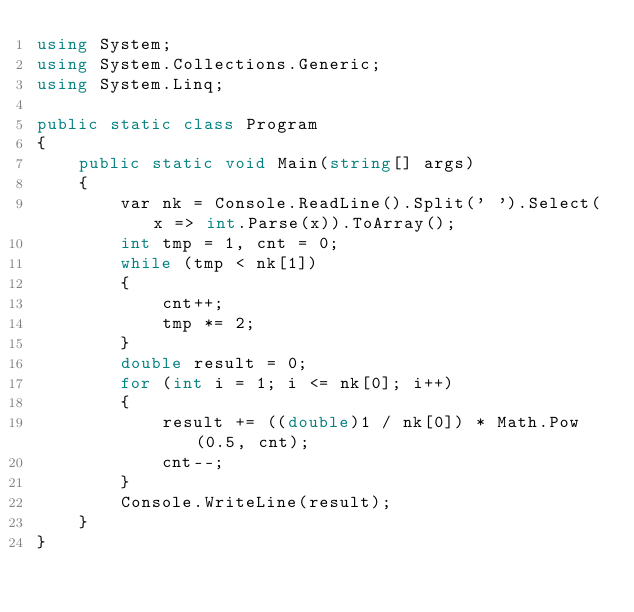Convert code to text. <code><loc_0><loc_0><loc_500><loc_500><_C#_>using System;
using System.Collections.Generic;
using System.Linq;

public static class Program
{
    public static void Main(string[] args)
    {
        var nk = Console.ReadLine().Split(' ').Select(x => int.Parse(x)).ToArray();
        int tmp = 1, cnt = 0;
        while (tmp < nk[1])
        {
            cnt++;
            tmp *= 2;
        }
        double result = 0;
        for (int i = 1; i <= nk[0]; i++)
        {
            result += ((double)1 / nk[0]) * Math.Pow(0.5, cnt);
            cnt--;
        }
        Console.WriteLine(result);
    }
}</code> 